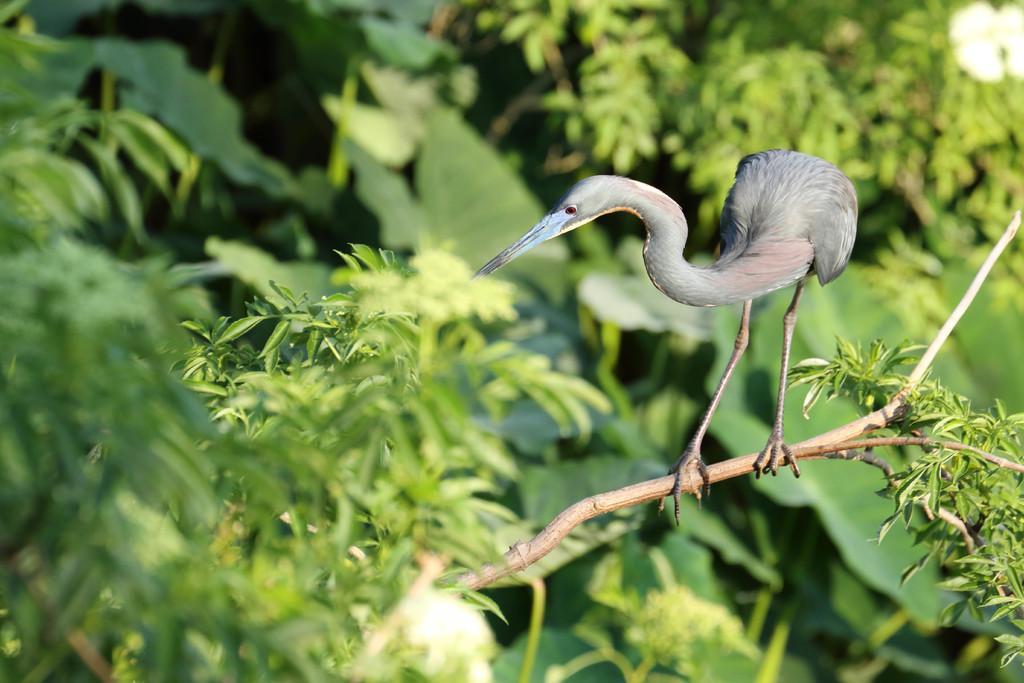Can you describe this image briefly? In this image we can see a bird on a tree. Behind the bird we can see a group of trees. 